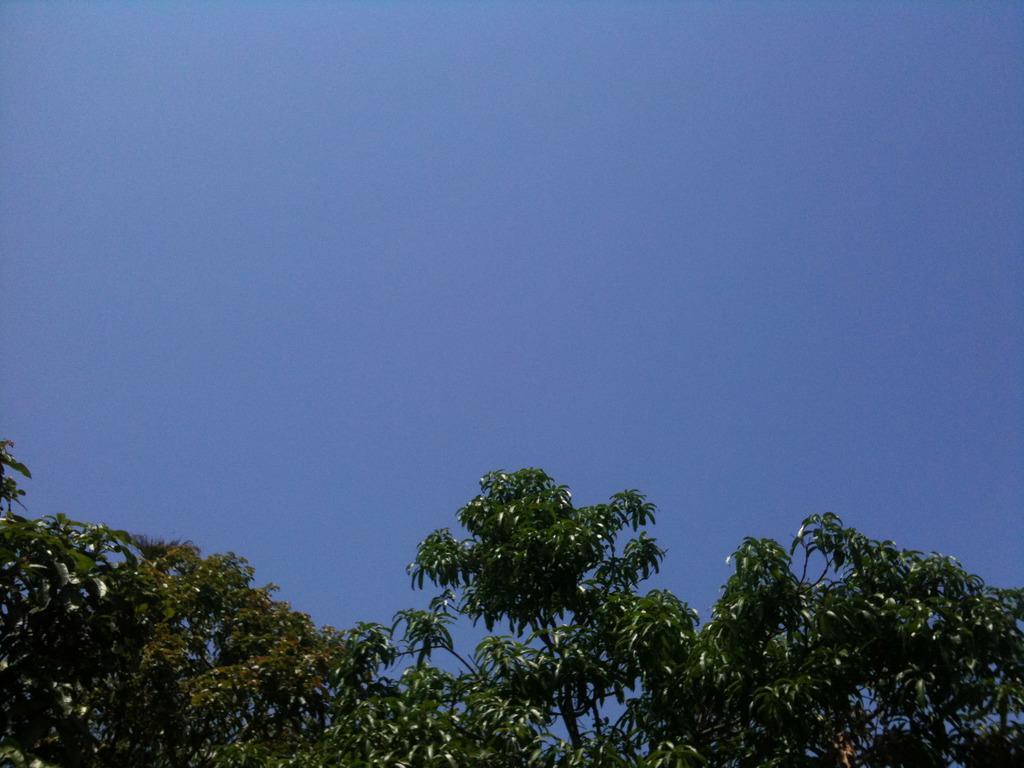In one or two sentences, can you explain what this image depicts? In this image we can see trees at the bottom. In the background there is sky. 